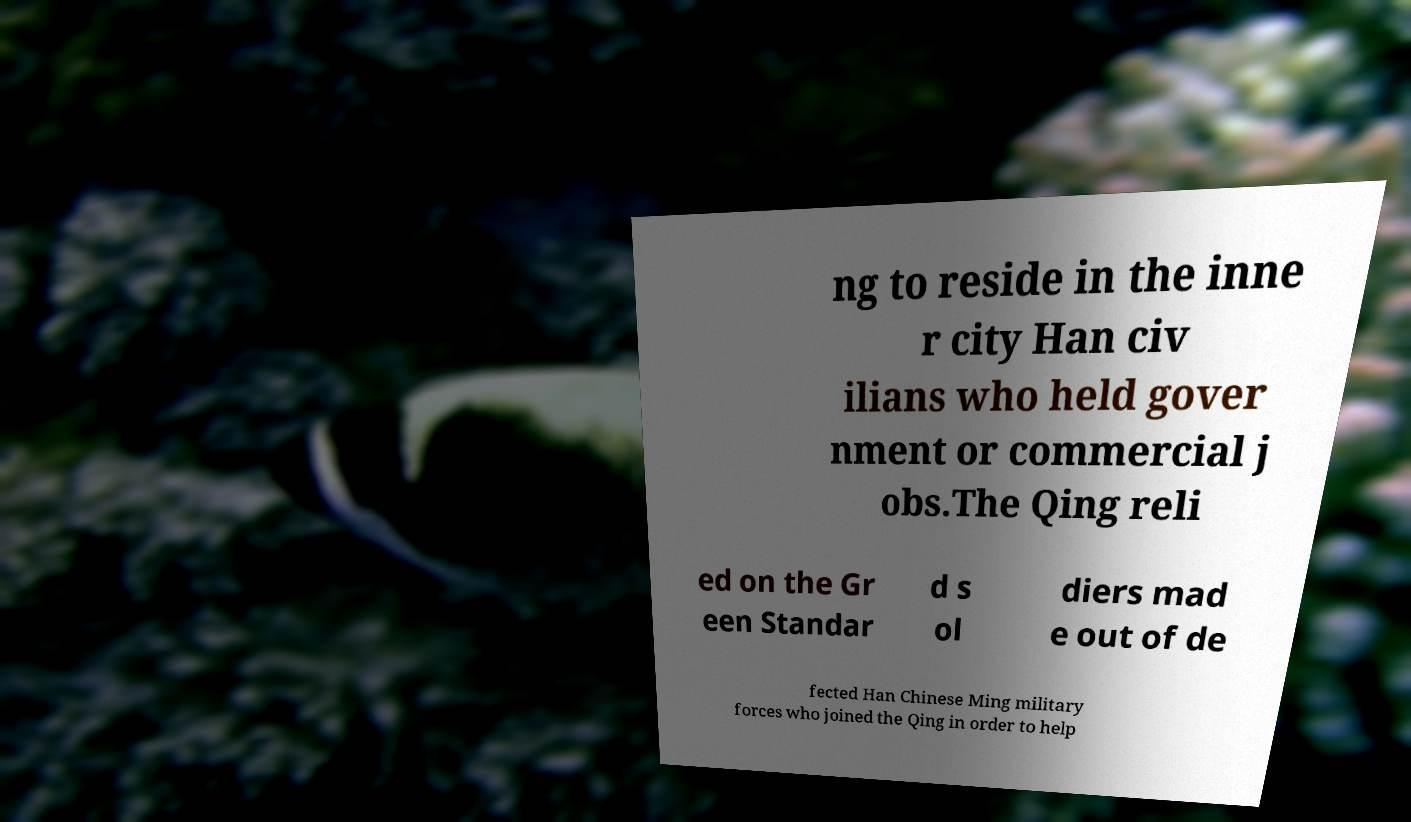Could you extract and type out the text from this image? ng to reside in the inne r city Han civ ilians who held gover nment or commercial j obs.The Qing reli ed on the Gr een Standar d s ol diers mad e out of de fected Han Chinese Ming military forces who joined the Qing in order to help 